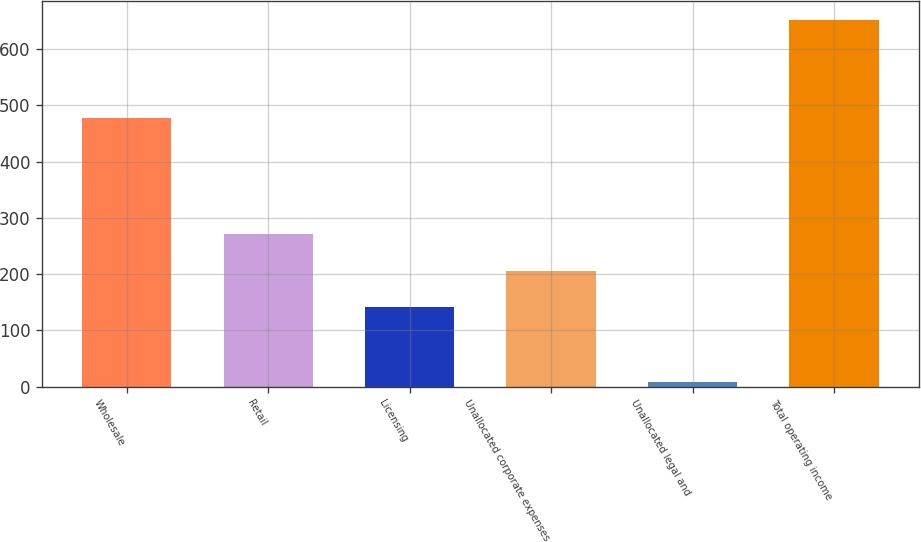<chart> <loc_0><loc_0><loc_500><loc_500><bar_chart><fcel>Wholesale<fcel>Retail<fcel>Licensing<fcel>Unallocated corporate expenses<fcel>Unallocated legal and<fcel>Total operating income<nl><fcel>477.8<fcel>270.6<fcel>141.6<fcel>206.1<fcel>7.6<fcel>652.6<nl></chart> 